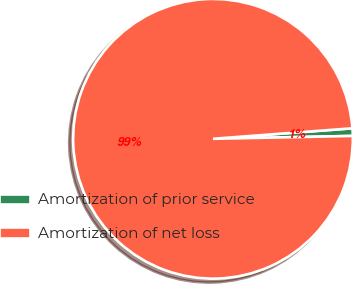<chart> <loc_0><loc_0><loc_500><loc_500><pie_chart><fcel>Amortization of prior service<fcel>Amortization of net loss<nl><fcel>0.87%<fcel>99.13%<nl></chart> 